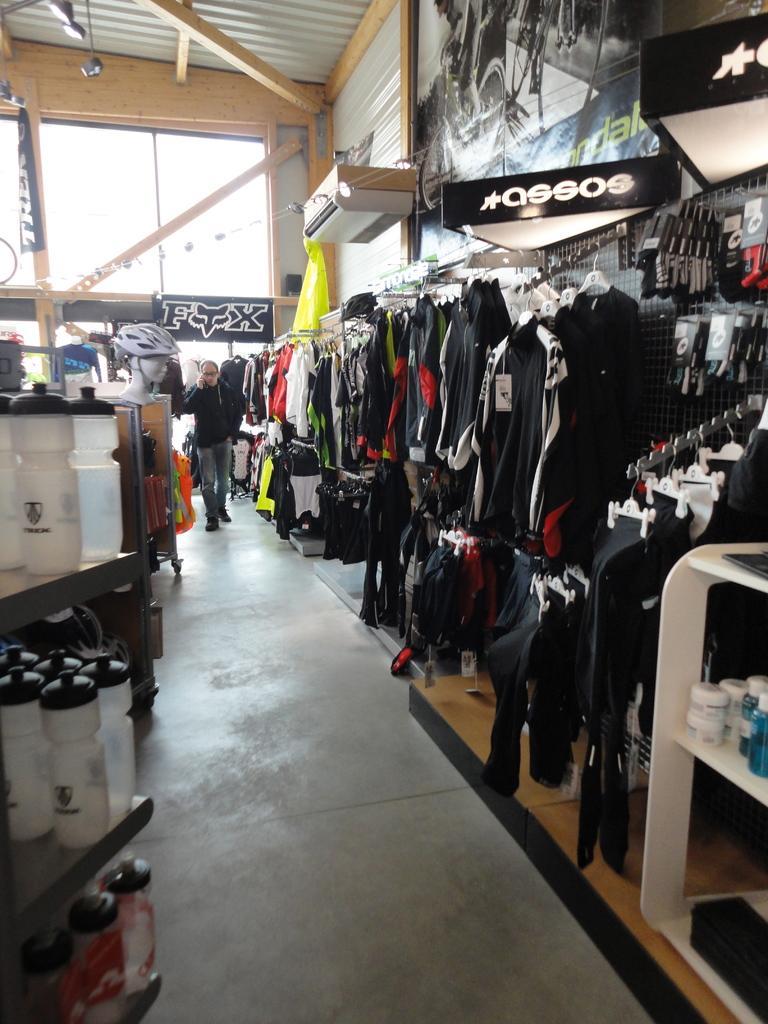Can you describe this image briefly? In this picture I can see the inside view of the clothing shop. On the right I can see many t-shirts and trouser which are hanging on the hangers. In the bottom left I can see some bottles on the white color racks. In the back there is a man who is holding a mobile phone. On the left I can see the water bottles, helmets and other objects on the wood racks. In the top left I can see the banner and lights which are hanging from the roof. 